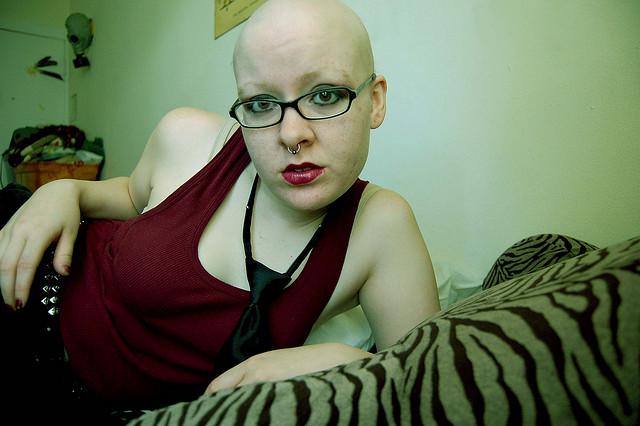Is this a male or female?
Answer briefly. Female. Is she wearing a tie?
Keep it brief. Yes. Does she have any hair?
Be succinct. No. Is the woman combing her hair?
Short answer required. No. How many faces can be seen?
Concise answer only. 1. What room is this?
Short answer required. Bedroom. What color is the woman's hair?
Give a very brief answer. No hair. What type of lens was used for this photo?
Short answer required. Regular. What figure is on the shirt?
Keep it brief. None. What color is the girl's tie?
Give a very brief answer. Black. Is the woman unhappy?
Give a very brief answer. No. 